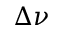Convert formula to latex. <formula><loc_0><loc_0><loc_500><loc_500>\Delta \nu</formula> 